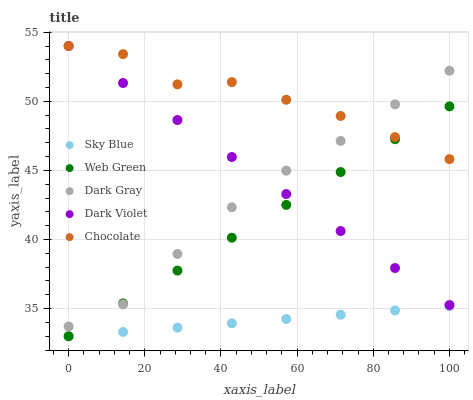Does Sky Blue have the minimum area under the curve?
Answer yes or no. Yes. Does Chocolate have the maximum area under the curve?
Answer yes or no. Yes. Does Dark Violet have the minimum area under the curve?
Answer yes or no. No. Does Dark Violet have the maximum area under the curve?
Answer yes or no. No. Is Web Green the smoothest?
Answer yes or no. Yes. Is Chocolate the roughest?
Answer yes or no. Yes. Is Sky Blue the smoothest?
Answer yes or no. No. Is Sky Blue the roughest?
Answer yes or no. No. Does Sky Blue have the lowest value?
Answer yes or no. Yes. Does Dark Violet have the lowest value?
Answer yes or no. No. Does Chocolate have the highest value?
Answer yes or no. Yes. Does Sky Blue have the highest value?
Answer yes or no. No. Is Sky Blue less than Chocolate?
Answer yes or no. Yes. Is Dark Gray greater than Sky Blue?
Answer yes or no. Yes. Does Dark Gray intersect Chocolate?
Answer yes or no. Yes. Is Dark Gray less than Chocolate?
Answer yes or no. No. Is Dark Gray greater than Chocolate?
Answer yes or no. No. Does Sky Blue intersect Chocolate?
Answer yes or no. No. 